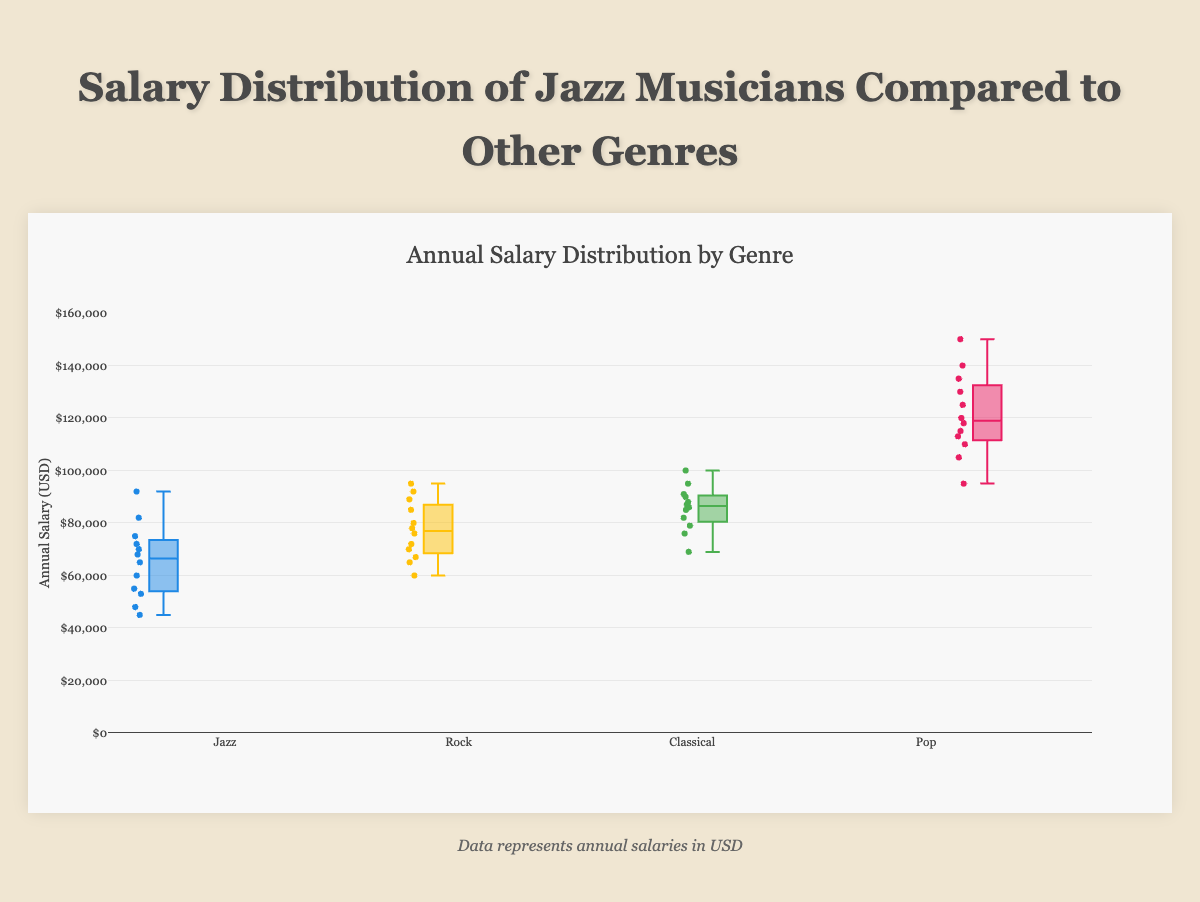What is the title of the chart? The title is displayed at the top of the chart and is labeled "Annual Salary Distribution by Genre" which provides the context of the figure.
Answer: Annual Salary Distribution by Genre Which genre has the highest median salary? The median salary can be identified by the line inside the box that represents each genre. For the Pop genre, the median line is higher than for the other genres.
Answer: Pop What is the range of salaries for Jazz musicians? The range of salaries is the difference between the highest and lowest data points in the Jazz box plot. The highest salary is 92,000, and the lowest salary is 45,000.
Answer: 45,000 to 92,000 How does the salary range of Jazz musicians compare to that of Classical musicians? The range of salaries for Jazz musicians is from 45,000 to 92,000, while for Classical musicians it is from 69,000 to 100,000. This shows the range for Classical musicians is higher, both at the low and high ends.
Answer: Jazz: 45,000 to 92,000; Classical: 69,000 to 100,000 Which genre has the largest interquartile range (IQR)? The IQR is shown by the height of the box for each genre. For the Pop genre, the height of the box (distance between Q1 and Q3) is larger when compared to the other genres.
Answer: Pop What is the median salary for Rock musicians? The median salary is found by looking at the line inside the box for the Rock musicians' box plot. This line corresponds approximately to 76,000.
Answer: 76,000 Is there any overlap in salaries between Jazz and Rock musicians? To determine overlap, observe if there are common salary ranges between the two groups. Salaries for Jazz musicians range from 45,000 to 92,000, and for Rock musicians, they range from 60,000 to 95,000. Overlap exists in the range of 60,000 to 92,000.
Answer: Yes, there is overlap from 60,000 to 92,000 Which genre has the smallest salary variation? Salary variation is indicated by the range (distance between the minimum and maximum values) and can also be inferred from the size of the IQR. Classical musicians have a smaller IQR and a less varied range compared to other genres.
Answer: Classical What is the maximum salary observed in the chart? The maximum salary is evident by the highest data point across all genres. Pop has a maximum salary of 150,000.
Answer: 150,000 How does the median salary of Pop musicians compare to that of Jazz musicians? Compare the median lines within the boxes for Pop and Jazz. The median for Pop (around 125,000) is significantly higher than that for Jazz (around 66,000).
Answer: Pop musicians' median salary is higher 